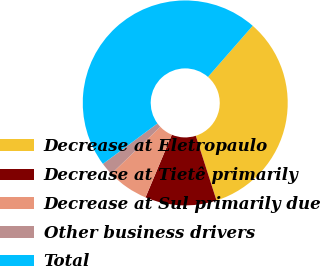Convert chart. <chart><loc_0><loc_0><loc_500><loc_500><pie_chart><fcel>Decrease at Eletropaulo<fcel>Decrease at Tietê primarily<fcel>Decrease at Sul primarily due<fcel>Other business drivers<fcel>Total<nl><fcel>33.63%<fcel>11.27%<fcel>6.49%<fcel>2.03%<fcel>46.59%<nl></chart> 